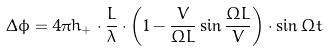Convert formula to latex. <formula><loc_0><loc_0><loc_500><loc_500>\Delta \phi = 4 \pi h _ { + } \cdot \frac { L } { \lambda } \cdot \left ( 1 - \frac { V } { \Omega L } \sin { \frac { \Omega L } { V } } \right ) \cdot \sin { \Omega t }</formula> 